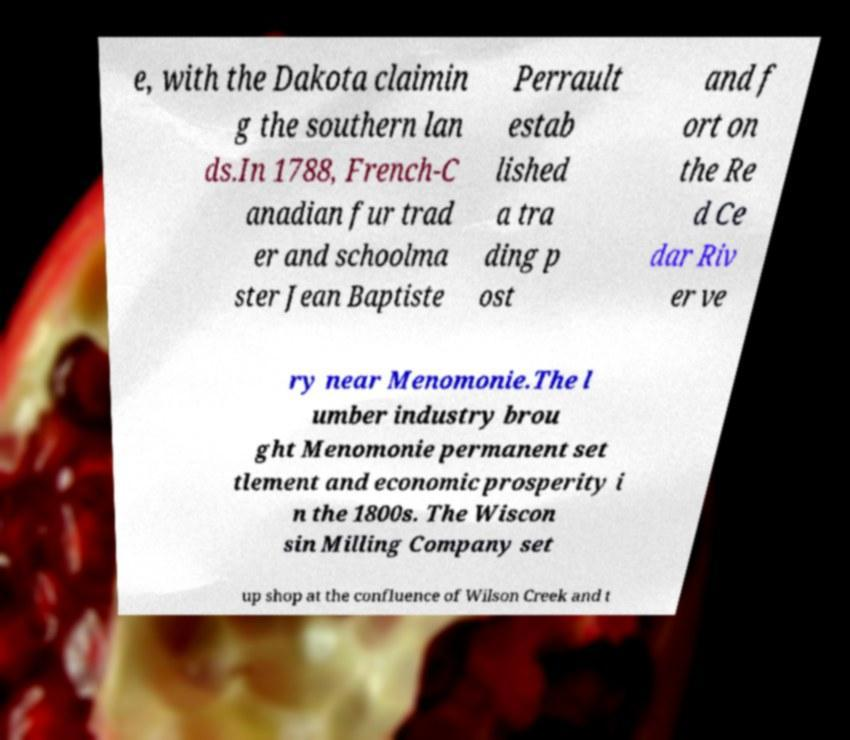For documentation purposes, I need the text within this image transcribed. Could you provide that? e, with the Dakota claimin g the southern lan ds.In 1788, French-C anadian fur trad er and schoolma ster Jean Baptiste Perrault estab lished a tra ding p ost and f ort on the Re d Ce dar Riv er ve ry near Menomonie.The l umber industry brou ght Menomonie permanent set tlement and economic prosperity i n the 1800s. The Wiscon sin Milling Company set up shop at the confluence of Wilson Creek and t 